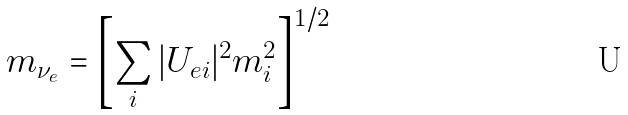<formula> <loc_0><loc_0><loc_500><loc_500>m _ { \nu _ { e } } = \left [ \sum _ { i } | U _ { e i } | ^ { 2 } m _ { i } ^ { 2 } \right ] ^ { 1 / 2 }</formula> 